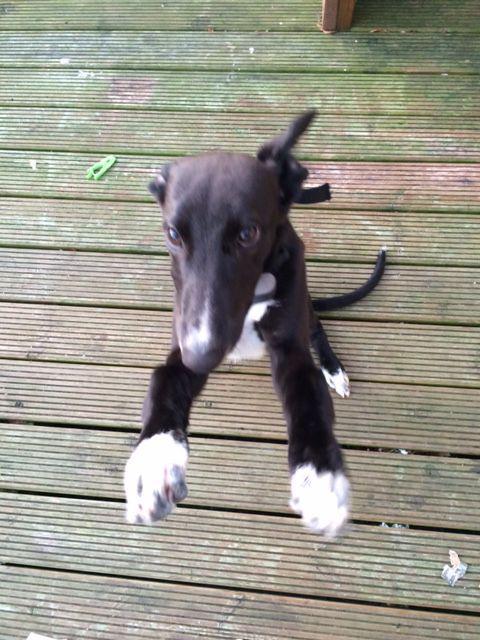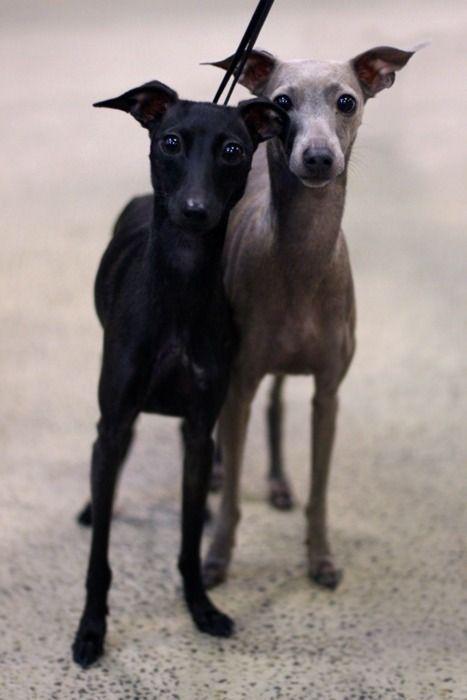The first image is the image on the left, the second image is the image on the right. Analyze the images presented: Is the assertion "Each Miniature Greyhound dog is standing on all four legs." valid? Answer yes or no. No. The first image is the image on the left, the second image is the image on the right. Examine the images to the left and right. Is the description "An image shows a non-costumed dog with a black face and body, and white paws and chest." accurate? Answer yes or no. Yes. 